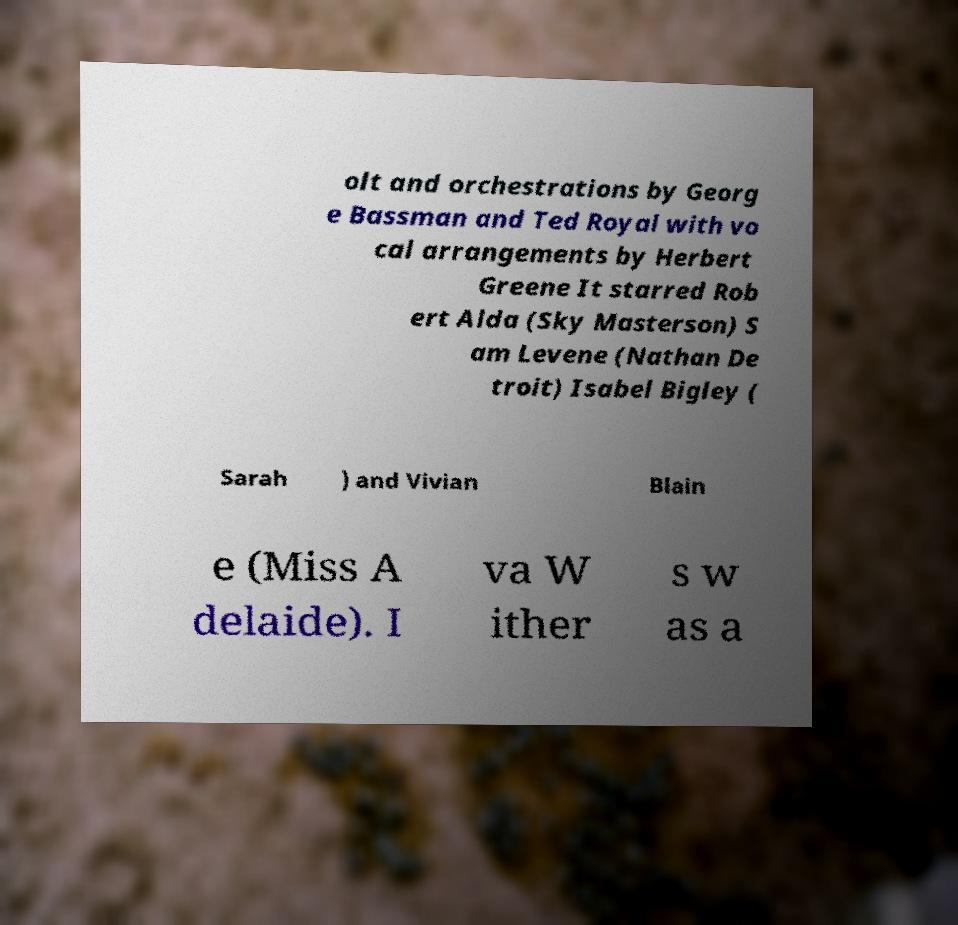Please read and relay the text visible in this image. What does it say? olt and orchestrations by Georg e Bassman and Ted Royal with vo cal arrangements by Herbert Greene It starred Rob ert Alda (Sky Masterson) S am Levene (Nathan De troit) Isabel Bigley ( Sarah ) and Vivian Blain e (Miss A delaide). I va W ither s w as a 